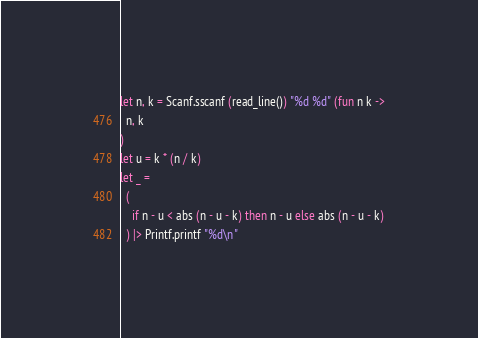<code> <loc_0><loc_0><loc_500><loc_500><_OCaml_>let n, k = Scanf.sscanf (read_line()) "%d %d" (fun n k ->
  n, k
)
let u = k * (n / k)
let _ = 
  (
    if n - u < abs (n - u - k) then n - u else abs (n - u - k)
  ) |> Printf.printf "%d\n"
</code> 